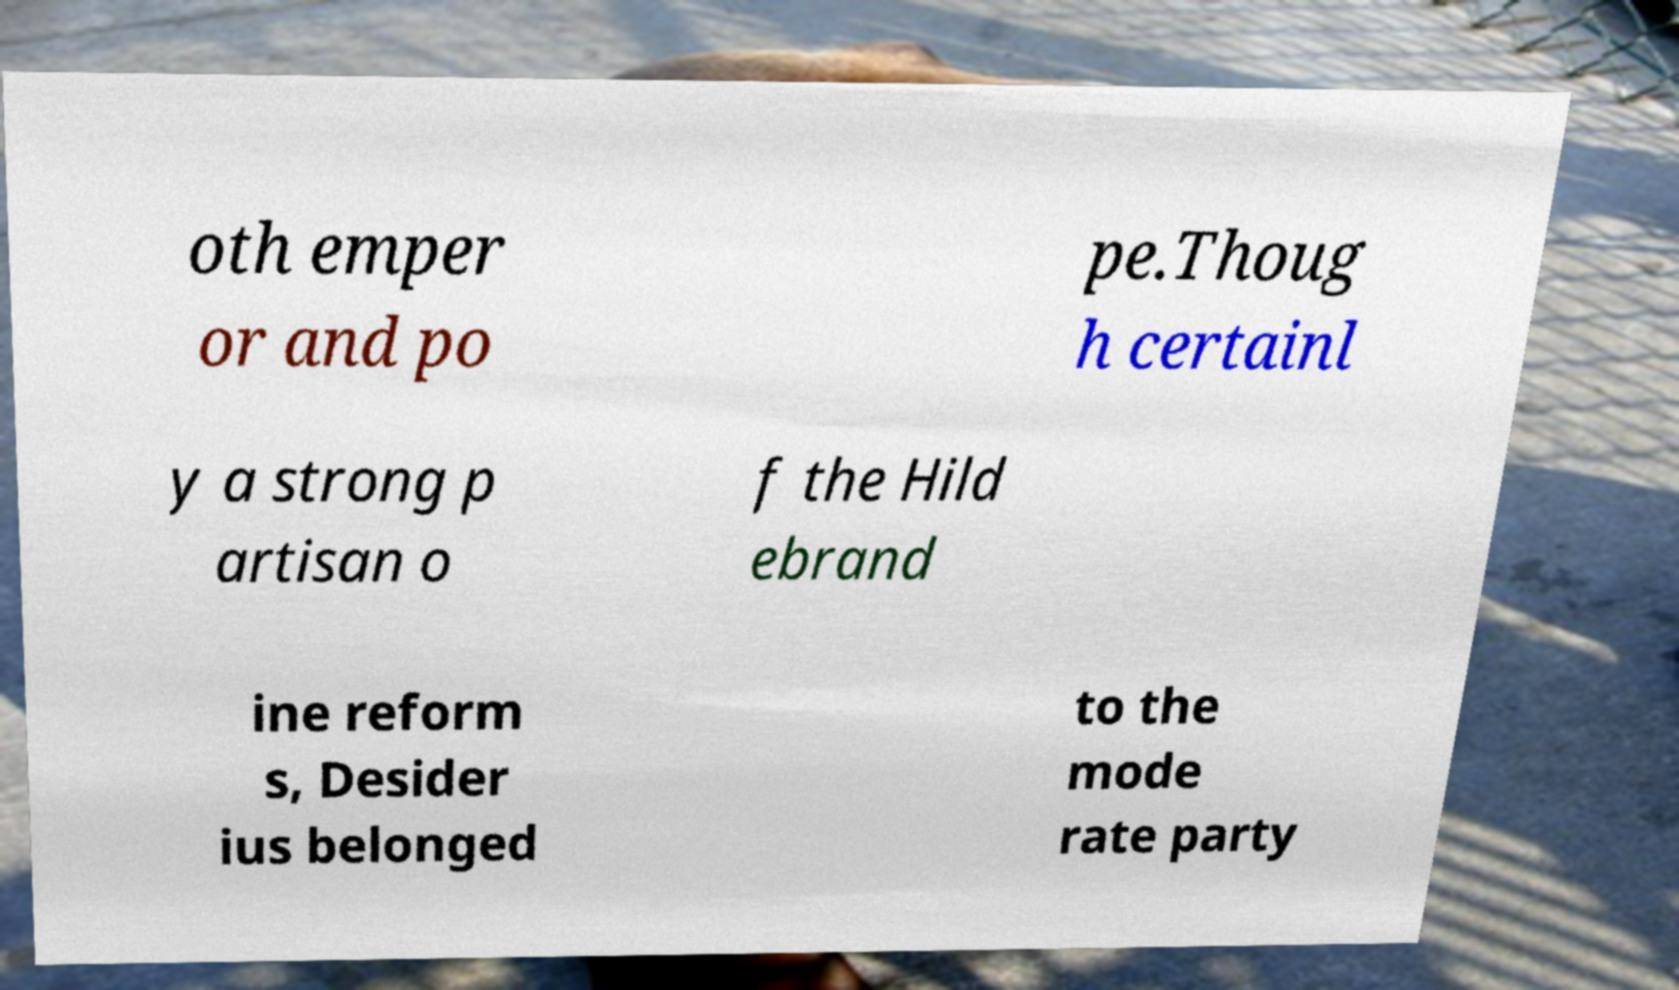For documentation purposes, I need the text within this image transcribed. Could you provide that? oth emper or and po pe.Thoug h certainl y a strong p artisan o f the Hild ebrand ine reform s, Desider ius belonged to the mode rate party 